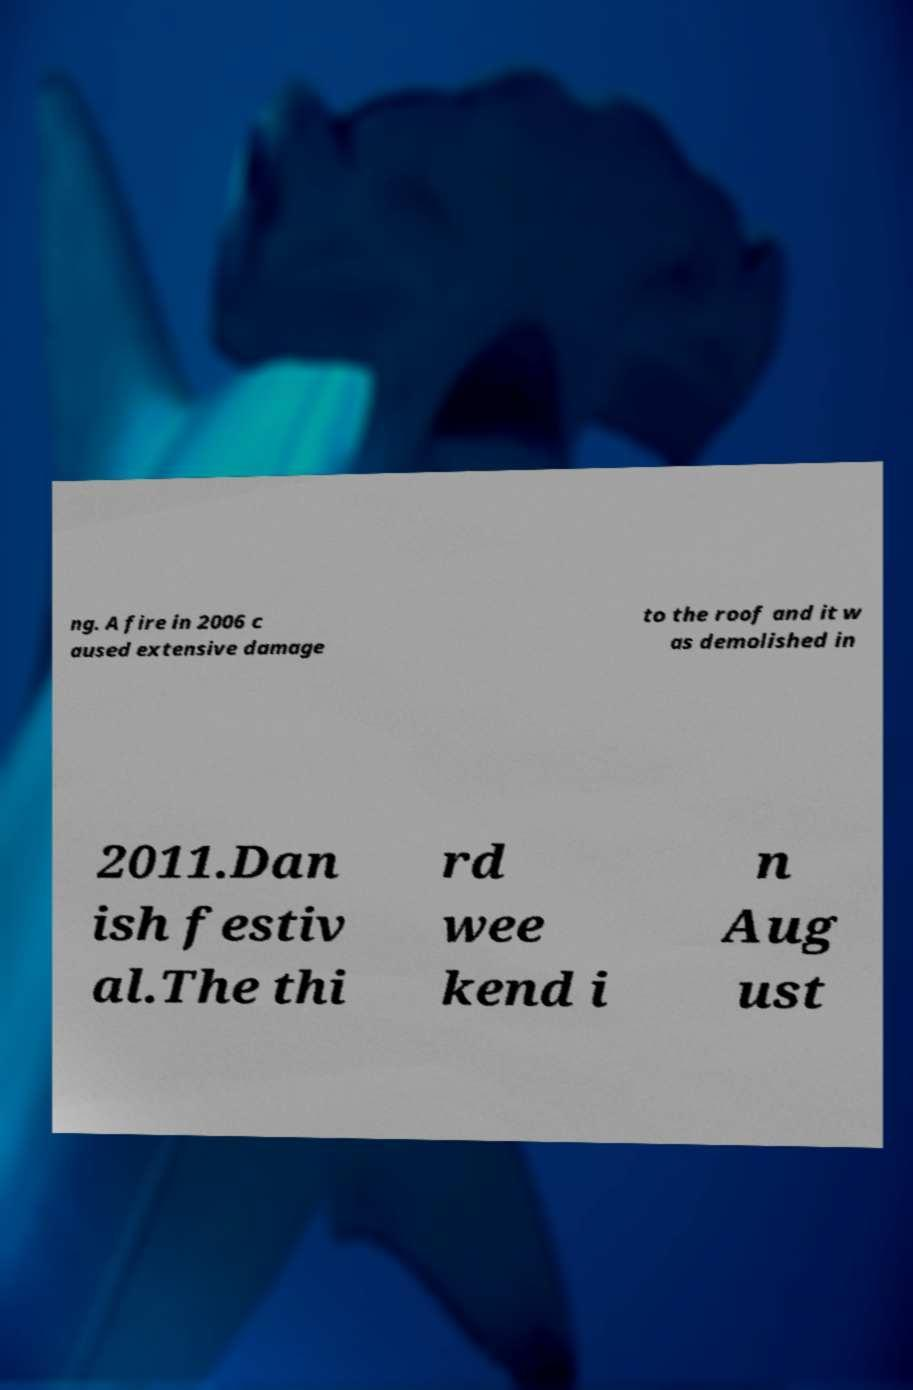Please read and relay the text visible in this image. What does it say? ng. A fire in 2006 c aused extensive damage to the roof and it w as demolished in 2011.Dan ish festiv al.The thi rd wee kend i n Aug ust 